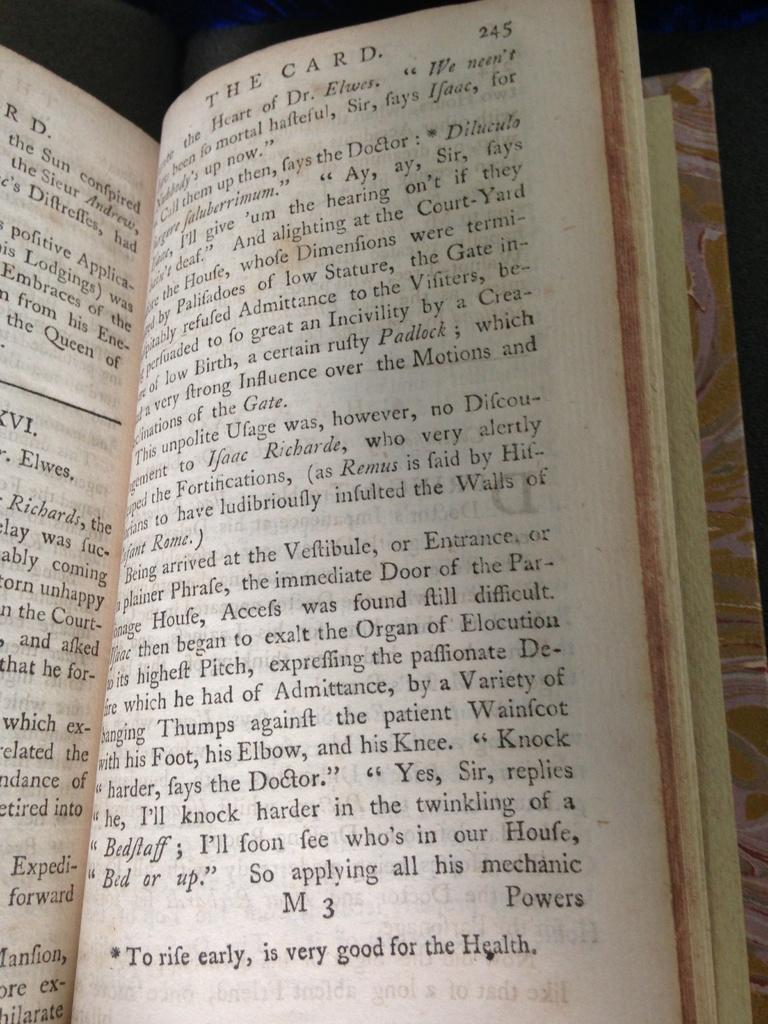Provide a one-sentence caption for the provided image. A book called The Card open to page 245. 